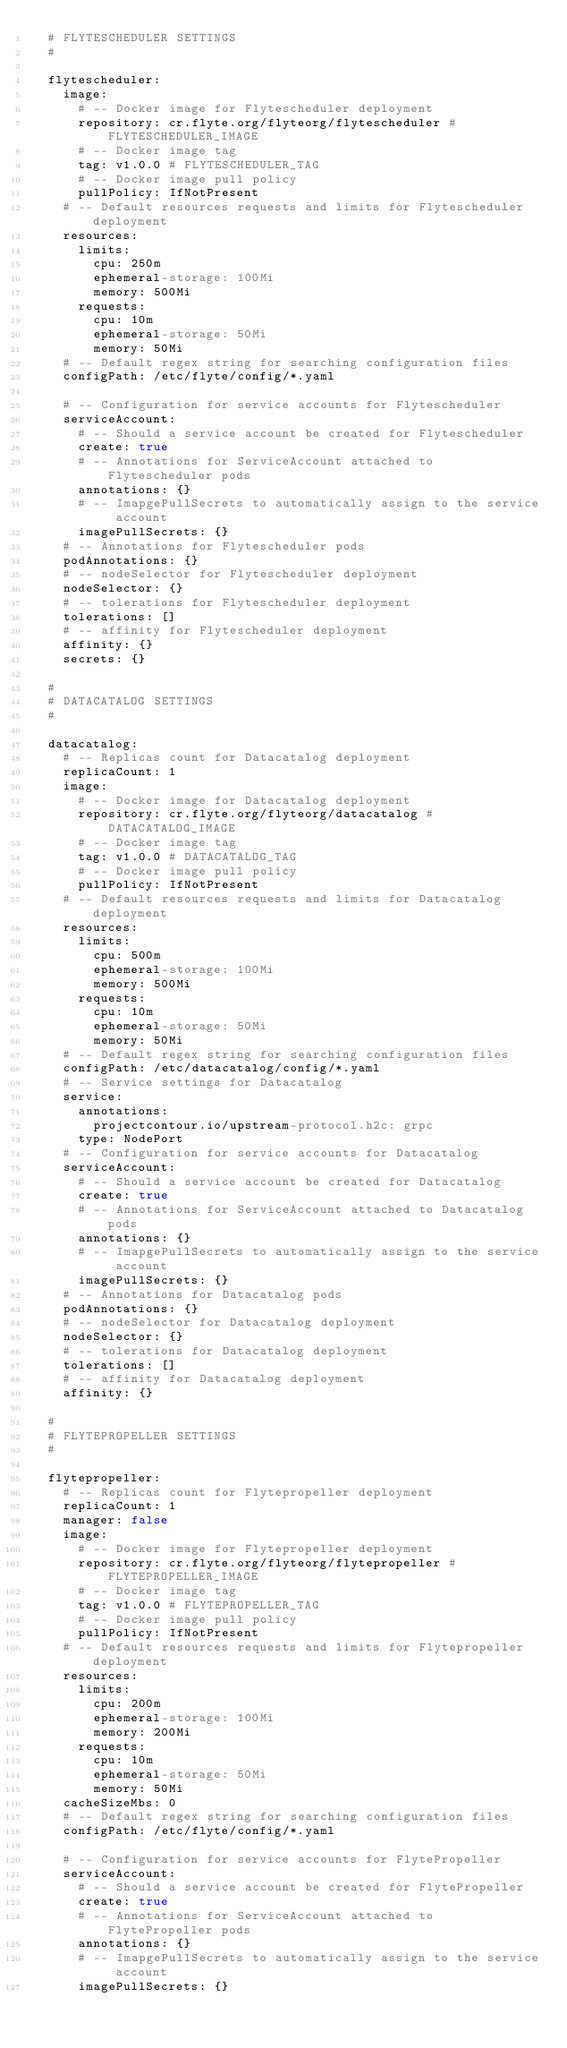<code> <loc_0><loc_0><loc_500><loc_500><_YAML_>  # FLYTESCHEDULER SETTINGS
  #

  flytescheduler:
    image:
      # -- Docker image for Flytescheduler deployment
      repository: cr.flyte.org/flyteorg/flytescheduler # FLYTESCHEDULER_IMAGE
      # -- Docker image tag
      tag: v1.0.0 # FLYTESCHEDULER_TAG
      # -- Docker image pull policy
      pullPolicy: IfNotPresent
    # -- Default resources requests and limits for Flytescheduler deployment
    resources:
      limits:
        cpu: 250m
        ephemeral-storage: 100Mi
        memory: 500Mi
      requests:
        cpu: 10m
        ephemeral-storage: 50Mi
        memory: 50Mi
    # -- Default regex string for searching configuration files
    configPath: /etc/flyte/config/*.yaml

    # -- Configuration for service accounts for Flytescheduler
    serviceAccount:
      # -- Should a service account be created for Flytescheduler
      create: true
      # -- Annotations for ServiceAccount attached to Flytescheduler pods
      annotations: {}
      # -- ImapgePullSecrets to automatically assign to the service account
      imagePullSecrets: {}
    # -- Annotations for Flytescheduler pods
    podAnnotations: {}
    # -- nodeSelector for Flytescheduler deployment
    nodeSelector: {}
    # -- tolerations for Flytescheduler deployment
    tolerations: []
    # -- affinity for Flytescheduler deployment
    affinity: {}
    secrets: {}

  #
  # DATACATALOG SETTINGS
  #

  datacatalog:
    # -- Replicas count for Datacatalog deployment
    replicaCount: 1
    image:
      # -- Docker image for Datacatalog deployment
      repository: cr.flyte.org/flyteorg/datacatalog # DATACATALOG_IMAGE
      # -- Docker image tag
      tag: v1.0.0 # DATACATALOG_TAG
      # -- Docker image pull policy
      pullPolicy: IfNotPresent
    # -- Default resources requests and limits for Datacatalog deployment
    resources:
      limits:
        cpu: 500m
        ephemeral-storage: 100Mi
        memory: 500Mi
      requests:
        cpu: 10m
        ephemeral-storage: 50Mi
        memory: 50Mi
    # -- Default regex string for searching configuration files
    configPath: /etc/datacatalog/config/*.yaml
    # -- Service settings for Datacatalog
    service:
      annotations:
        projectcontour.io/upstream-protocol.h2c: grpc
      type: NodePort
    # -- Configuration for service accounts for Datacatalog
    serviceAccount:
      # -- Should a service account be created for Datacatalog
      create: true
      # -- Annotations for ServiceAccount attached to Datacatalog pods
      annotations: {}
      # -- ImapgePullSecrets to automatically assign to the service account
      imagePullSecrets: {}
    # -- Annotations for Datacatalog pods
    podAnnotations: {}
    # -- nodeSelector for Datacatalog deployment
    nodeSelector: {}
    # -- tolerations for Datacatalog deployment
    tolerations: []
    # -- affinity for Datacatalog deployment
    affinity: {}

  #
  # FLYTEPROPELLER SETTINGS
  #

  flytepropeller:
    # -- Replicas count for Flytepropeller deployment
    replicaCount: 1
    manager: false
    image:
      # -- Docker image for Flytepropeller deployment
      repository: cr.flyte.org/flyteorg/flytepropeller # FLYTEPROPELLER_IMAGE
      # -- Docker image tag
      tag: v1.0.0 # FLYTEPROPELLER_TAG
      # -- Docker image pull policy
      pullPolicy: IfNotPresent
    # -- Default resources requests and limits for Flytepropeller deployment
    resources:
      limits:
        cpu: 200m
        ephemeral-storage: 100Mi
        memory: 200Mi
      requests:
        cpu: 10m
        ephemeral-storage: 50Mi
        memory: 50Mi
    cacheSizeMbs: 0
    # -- Default regex string for searching configuration files
    configPath: /etc/flyte/config/*.yaml

    # -- Configuration for service accounts for FlytePropeller
    serviceAccount:
      # -- Should a service account be created for FlytePropeller
      create: true
      # -- Annotations for ServiceAccount attached to FlytePropeller pods
      annotations: {}
      # -- ImapgePullSecrets to automatically assign to the service account
      imagePullSecrets: {}</code> 